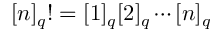<formula> <loc_0><loc_0><loc_500><loc_500>[ n ] _ { q } ! = [ 1 ] _ { q } [ 2 ] _ { q } \cdots [ n ] _ { q }</formula> 